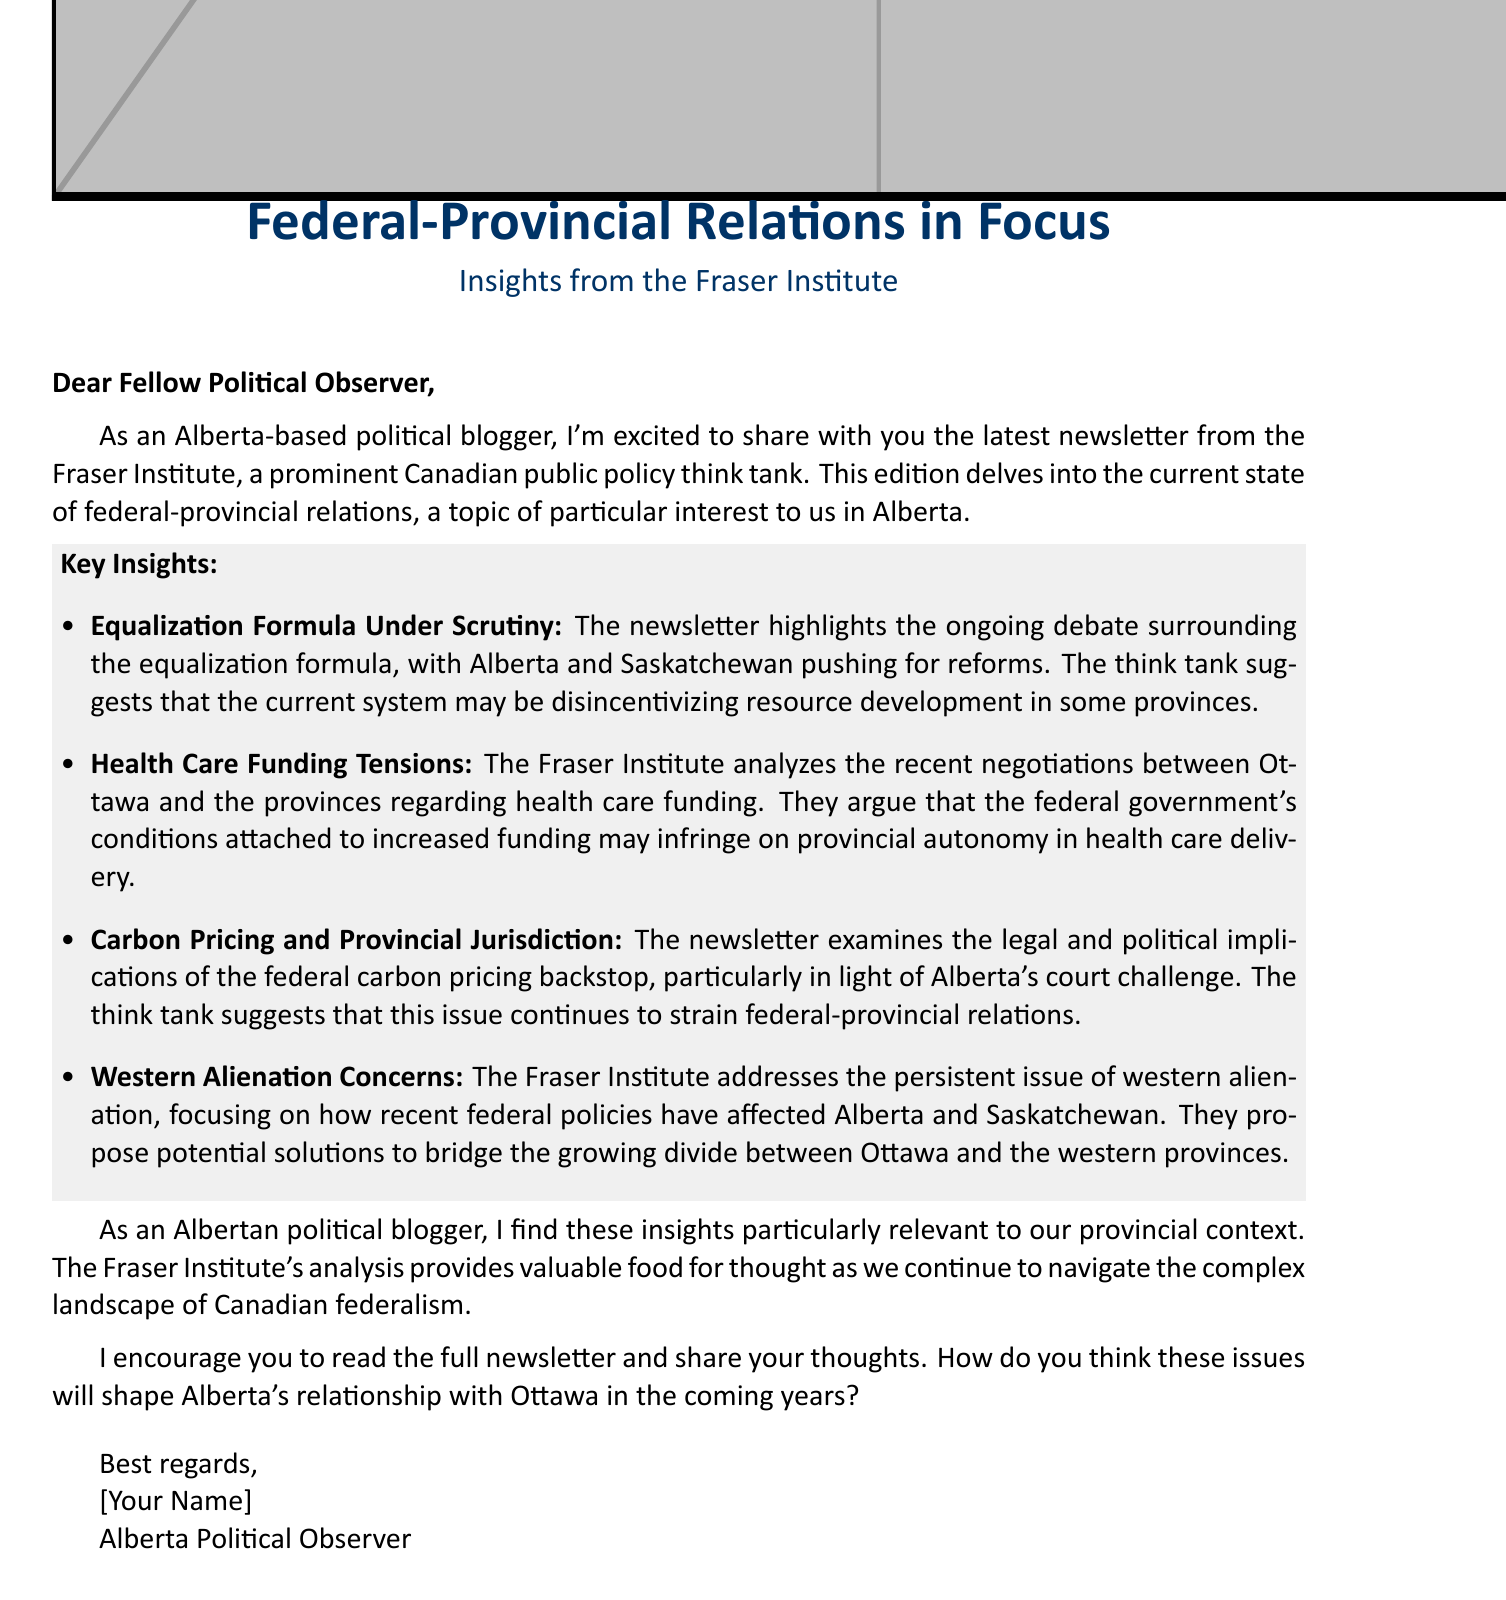What is the newsletter's focus topic? The newsletter focuses on federal-provincial relations, which is highlighted in the introduction.
Answer: federal-provincial relations Which provinces are mentioned regarding the equalization formula? Alberta and Saskatchewan are specifically mentioned in the context of the equalization formula debate.
Answer: Alberta and Saskatchewan What does the Fraser Institute analyze in relation to health care? The Fraser Institute analyzes the recent negotiations between Ottawa and the provinces about health care funding.
Answer: health care funding What legal issue is examined concerning carbon pricing? The legal implications of the federal carbon pricing backstop are discussed, particularly regarding Alberta's court challenge.
Answer: Alberta's court challenge What concern is raised about recent federal policies? The newsletter addresses the persistent issue of western alienation, focusing on its effects on Alberta and Saskatchewan.
Answer: western alienation What is encouraged at the end of the email? The author encourages readers to read the full newsletter and share their thoughts on the discussed issues.
Answer: read the full newsletter and share your thoughts Who is the message addressed to? The greeting specifies that the message is addressed to "Fellow Political Observer," indicating the intended audience.
Answer: Fellow Political Observer What is the signature title of the sender? The signature title of the sender is stated at the end of the email.
Answer: Alberta Political Observer 